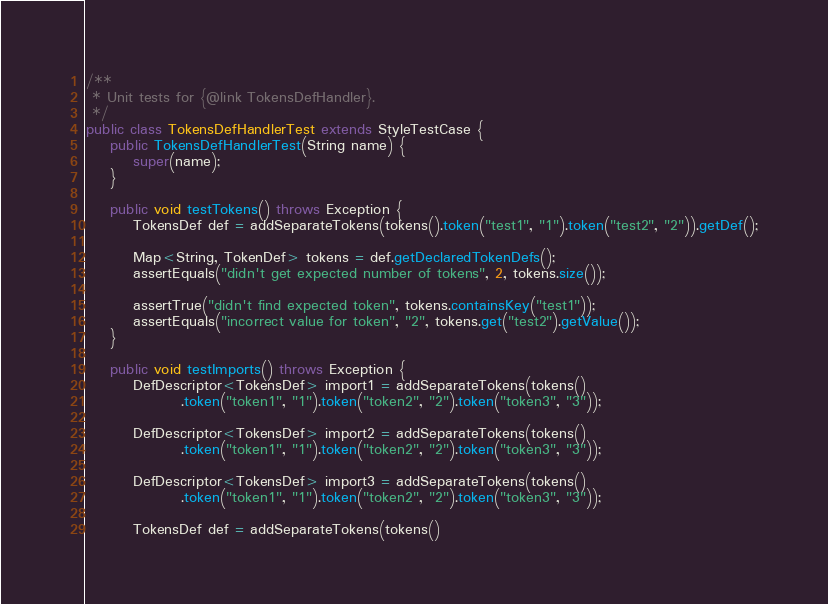<code> <loc_0><loc_0><loc_500><loc_500><_Java_>/**
 * Unit tests for {@link TokensDefHandler}.
 */
public class TokensDefHandlerTest extends StyleTestCase {
    public TokensDefHandlerTest(String name) {
        super(name);
    }

    public void testTokens() throws Exception {
        TokensDef def = addSeparateTokens(tokens().token("test1", "1").token("test2", "2")).getDef();

        Map<String, TokenDef> tokens = def.getDeclaredTokenDefs();
        assertEquals("didn't get expected number of tokens", 2, tokens.size());

        assertTrue("didn't find expected token", tokens.containsKey("test1"));
        assertEquals("incorrect value for token", "2", tokens.get("test2").getValue());
    }

    public void testImports() throws Exception {
        DefDescriptor<TokensDef> import1 = addSeparateTokens(tokens()
                .token("token1", "1").token("token2", "2").token("token3", "3"));

        DefDescriptor<TokensDef> import2 = addSeparateTokens(tokens()
                .token("token1", "1").token("token2", "2").token("token3", "3"));

        DefDescriptor<TokensDef> import3 = addSeparateTokens(tokens()
                .token("token1", "1").token("token2", "2").token("token3", "3"));

        TokensDef def = addSeparateTokens(tokens()</code> 